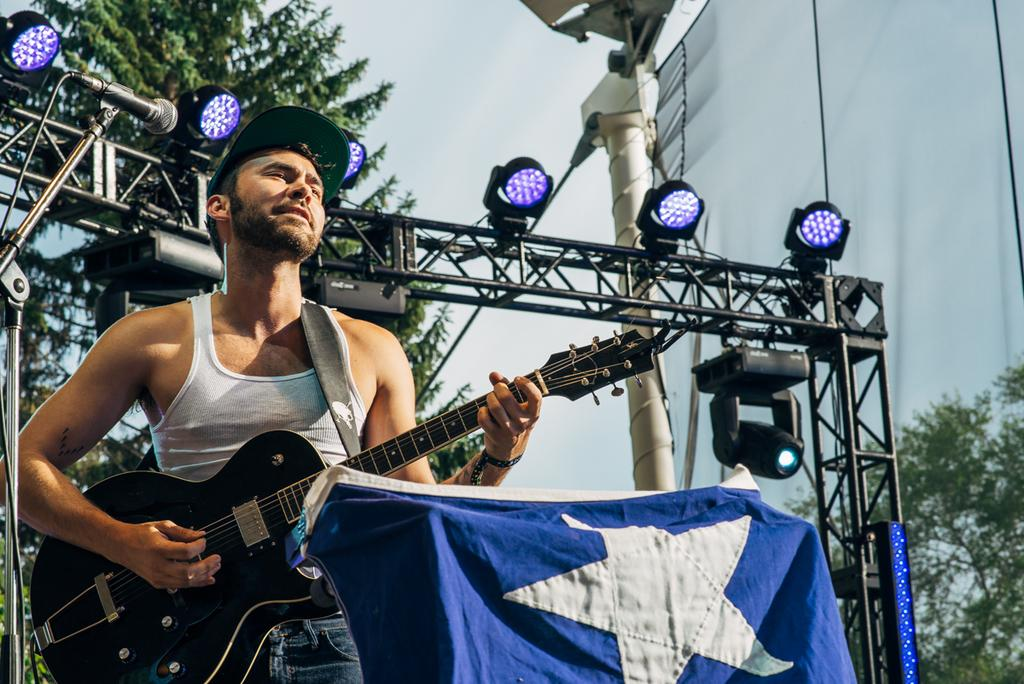Who is present in the image? There is a man in the image. What is the man doing in the image? The man is standing in the image. What object is the man holding in the image? The man is holding a guitar in the image. What can be seen in the background of the image? There are lights and trees in the background of the image. What type of clam is the man holding in the image? There is no clam present in the image; the man is holding a guitar. How does the queen relate to the man in the image? There is no queen present in the image, so it is not possible to determine any relationship between the man and a queen. 